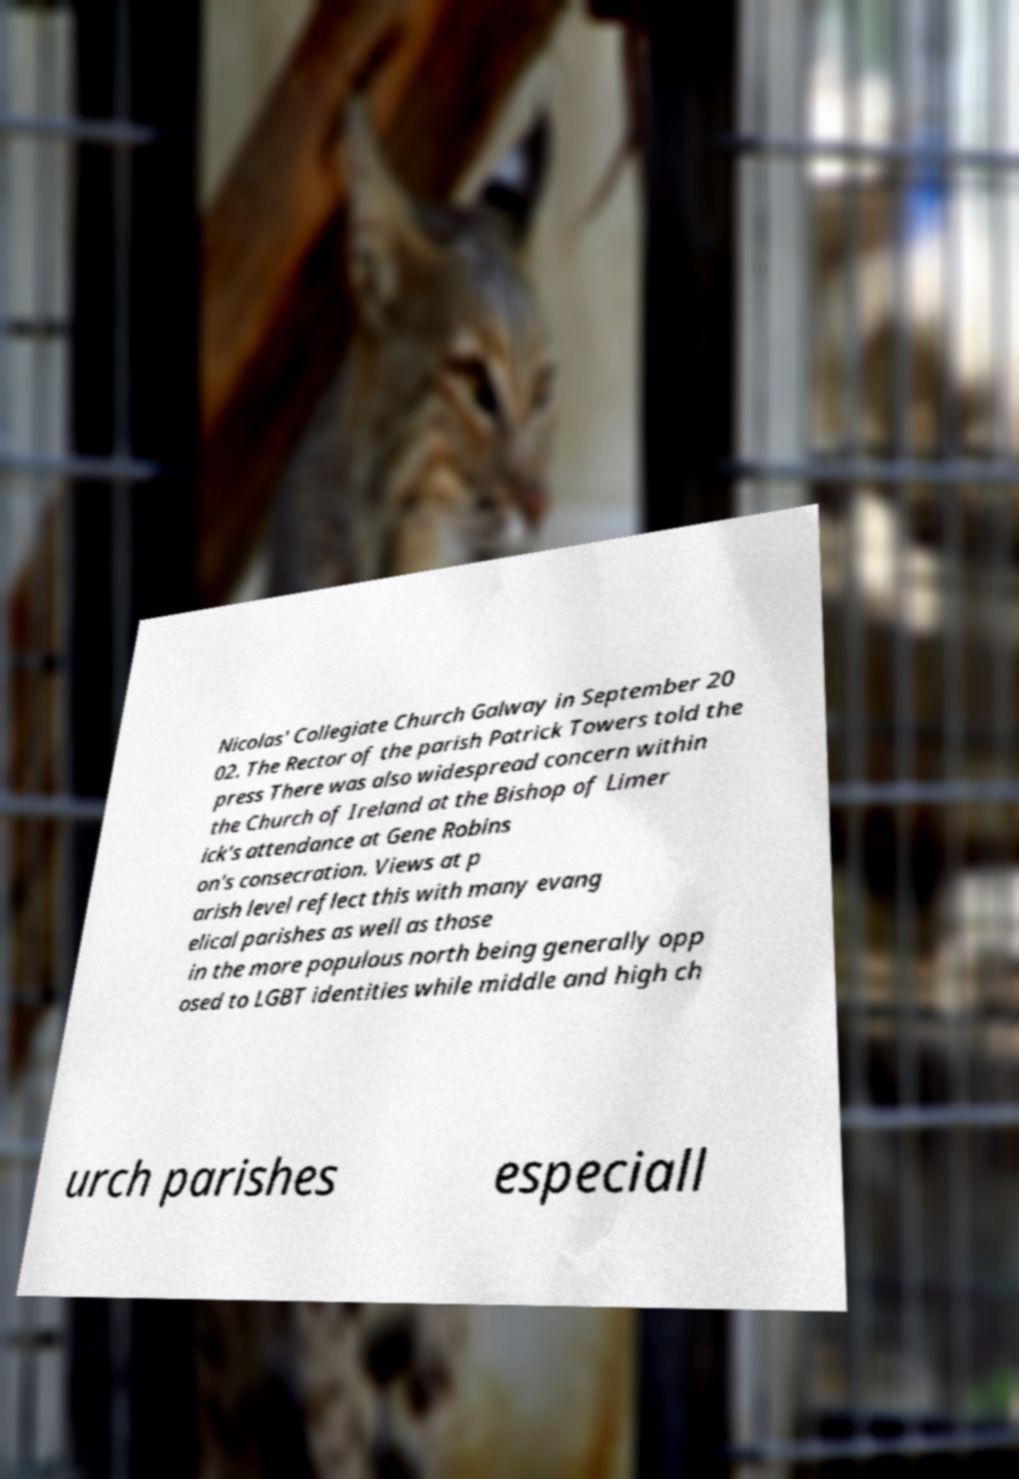Can you accurately transcribe the text from the provided image for me? Nicolas' Collegiate Church Galway in September 20 02. The Rector of the parish Patrick Towers told the press There was also widespread concern within the Church of Ireland at the Bishop of Limer ick's attendance at Gene Robins on's consecration. Views at p arish level reflect this with many evang elical parishes as well as those in the more populous north being generally opp osed to LGBT identities while middle and high ch urch parishes especiall 